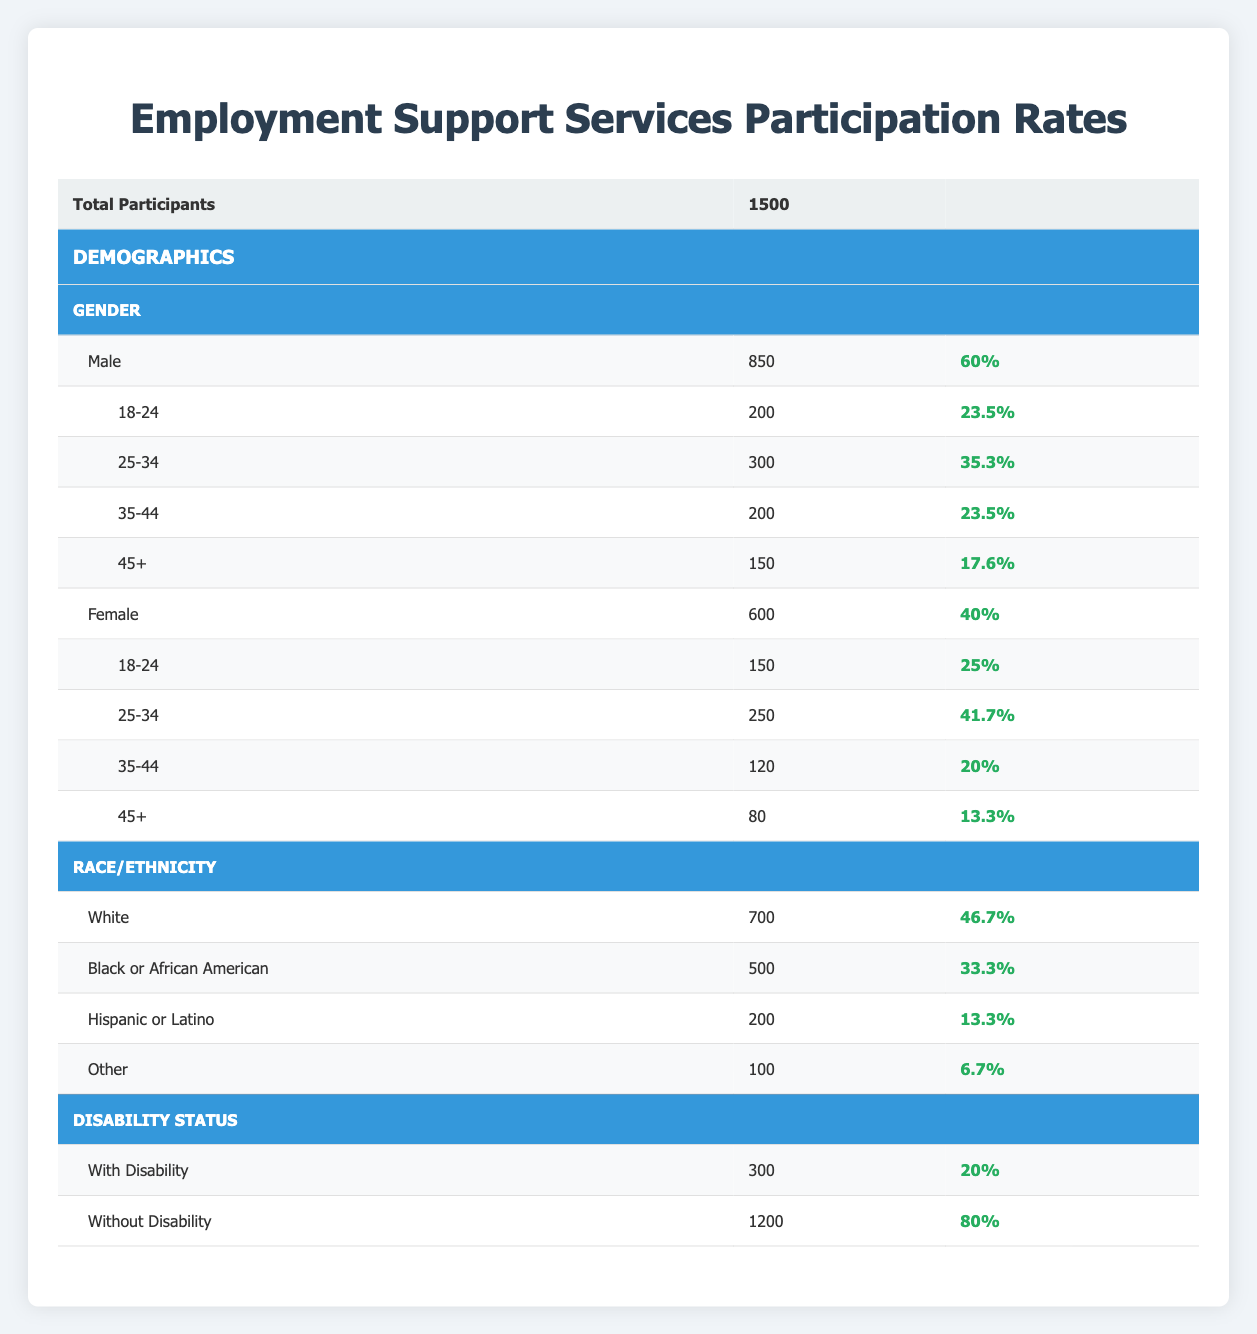What is the total number of participants in the Employment Support Services? The table states that the total number of participants is listed as 1500 at the beginning of the data.
Answer: 1500 What percentage of participants are female? The table shows that there are 600 female participants out of a total of 1500, so the percentage is (600/1500) * 100 = 40%.
Answer: 40% How many male participants are in the age group 25-34? The table indicates that there are 300 male participants in the age group 25-34 specifically listed under the Male section.
Answer: 300 What is the participation rate for individuals with disabilities? The participation rate for individuals classified as having a disability is noted in the table as 20% under the Disability Status section.
Answer: 20% Are there more participants in the 18-24 age group for females than males? The table shows 150 female participants in the 18-24 age group and 200 male participants. Since 200 is greater than 150, the answer is no.
Answer: No What is the difference in participation rates between the race categories White and Hispanic or Latino? The participation rate for White participants is 46.7% and for Hispanic or Latino participants is 13.3%. The difference is 46.7 - 13.3 = 33.4%.
Answer: 33.4% How many participants are without a disability, and what percentage does this represent? There are 1200 participants without a disability. To find the percentage, we calculate (1200/1500) * 100 = 80%.
Answer: 1200 and 80% Is the participation rate for males higher than that for females? The participation rate for males is 60% while for females it is 40%. Since 60% is indeed higher than 40%, the answer is yes.
Answer: Yes What age group has the lowest participation rate among males? The age group 45+ has the lowest participation rate for males, at 17.6%. Examining the various age groups shows all other age groups have higher rates.
Answer: 45+ Which race/ethnicity category has the lowest participation rate? The category labeled "Other" has the lowest participation rate recorded at 6.7% according to the Race/Ethnicity section of the table.
Answer: Other 